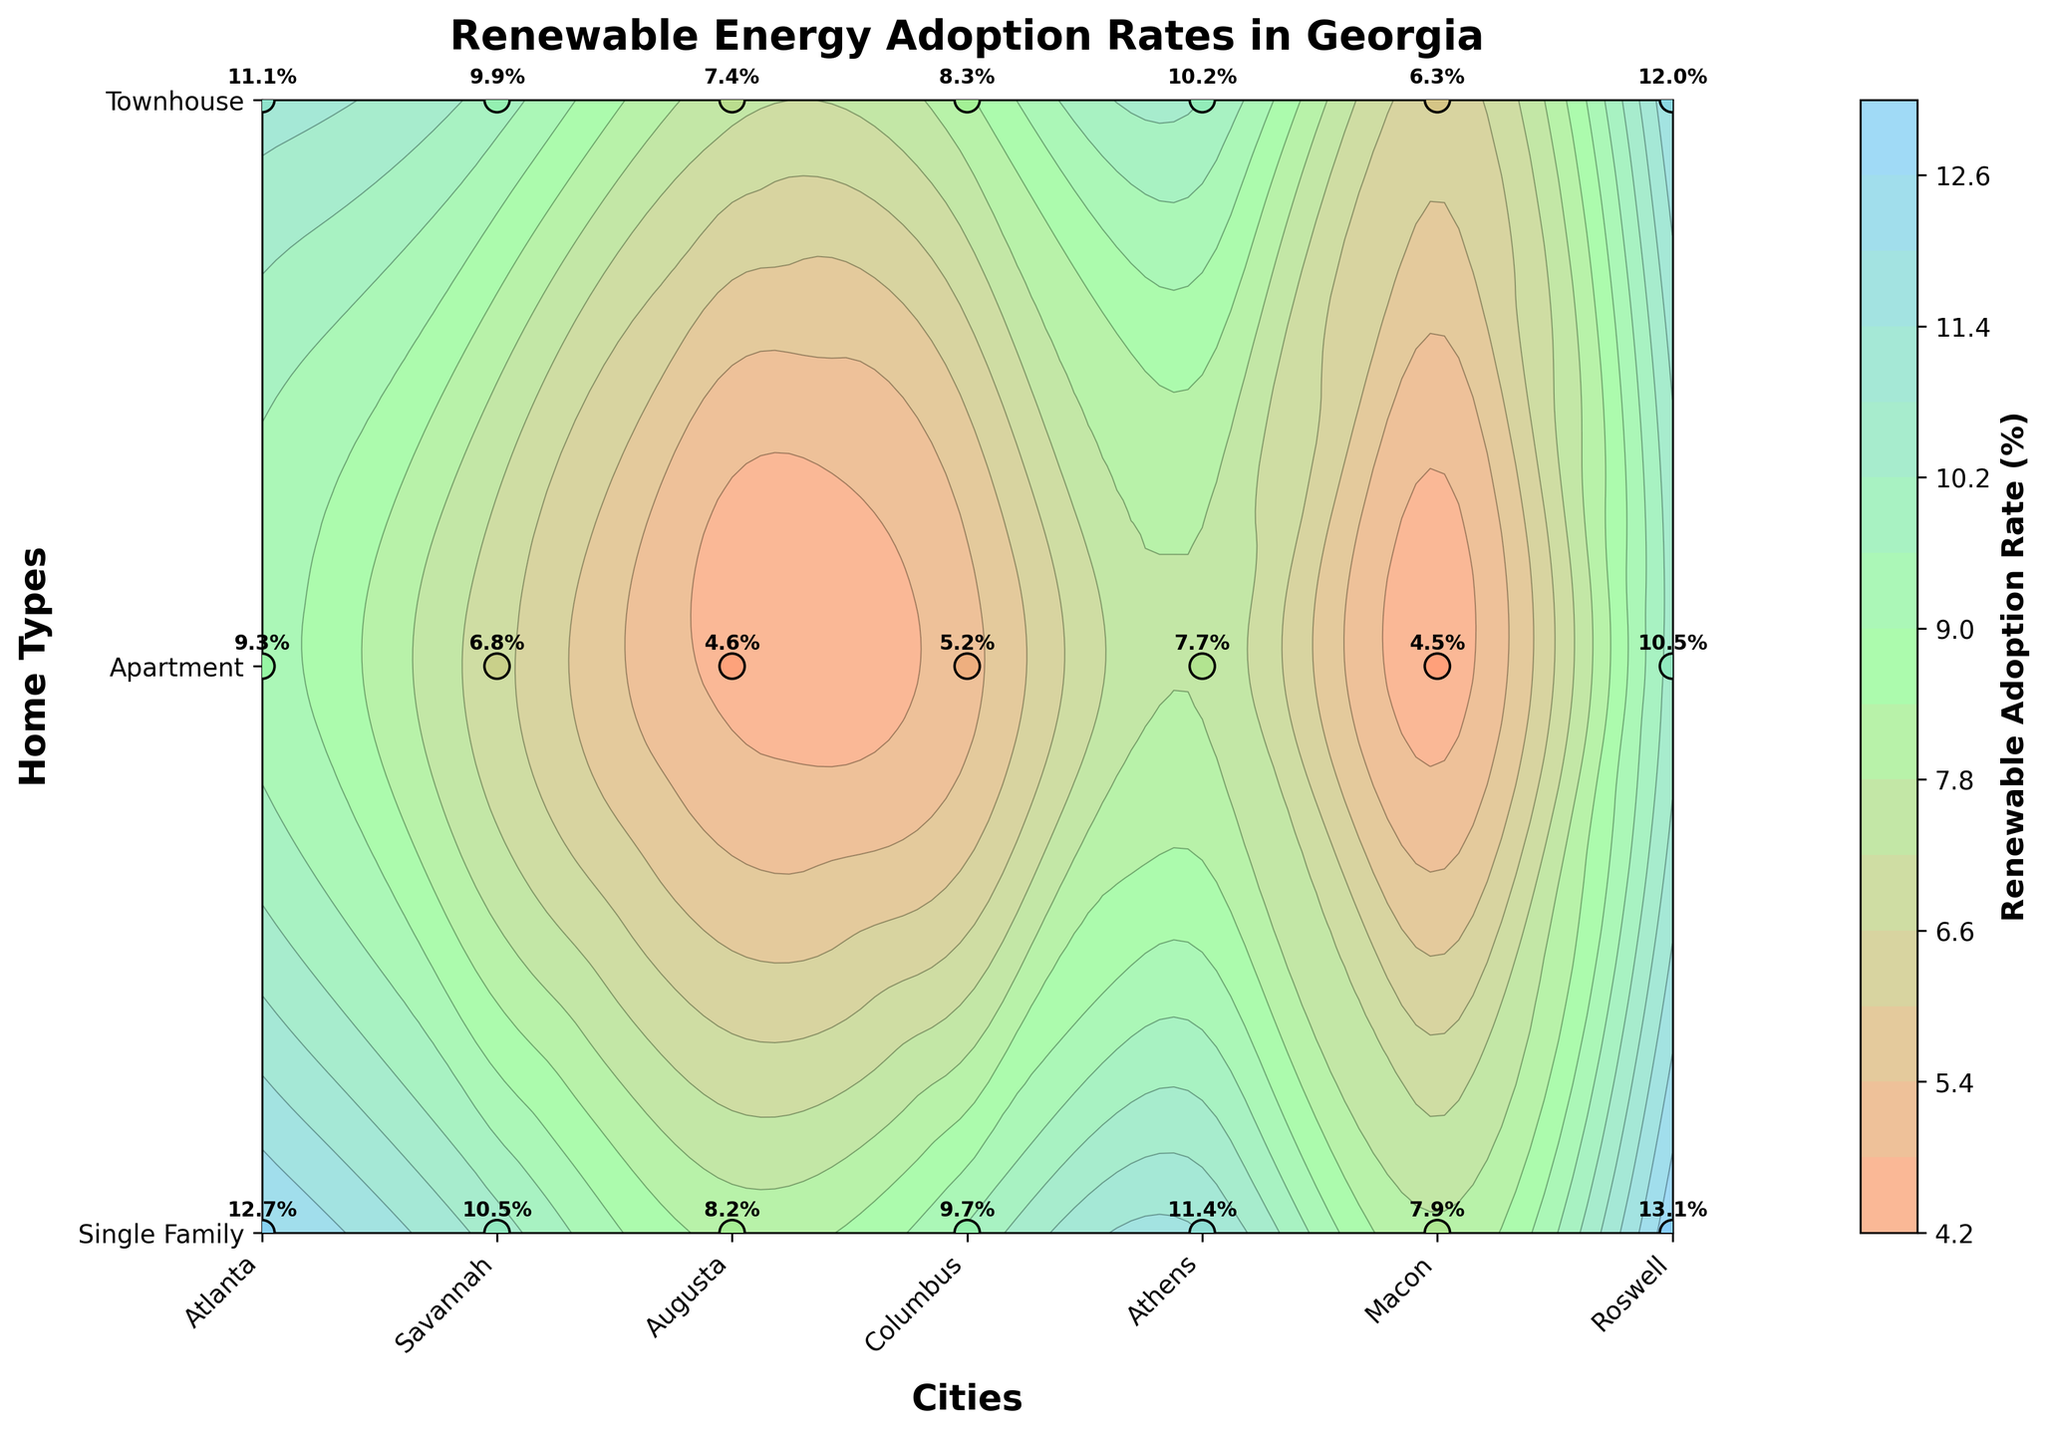What is the title of the plot? The title of the plot is displayed at the top center and usually provides a general idea about the plot's subject.
Answer: Renewable Energy Adoption Rates in Georgia Which city has the highest renewable adoption rate for single-family homes? Locate the single-family home type on the vertical axis and find the highest contour or label point across the horizontal axis representing different cities.
Answer: Roswell How many contour levels are present in the plot? Count the distinct color regions or refer to the contour level description in the legend or color bar.
Answer: 15 What is the renewable adoption rate for townhouses in Augusta? Locate Augusta on the horizontal axis and townhouses on the vertical axis, then find the corresponding label or contour value.
Answer: 7.4% Which city has the lowest renewable adoption rate for apartments? Compare the labeled rates for apartments across all cities displayed on the horizontal axis relative to apartments on the vertical axis.
Answer: Macon Which home type has the highest variation in renewable adoption rates across different cities? Observe the labels or colors across each horizontal strip representing a home type to determine which has the widest range or most significant color gradient.
Answer: Single Family What is the average renewable adoption rate for Atlanta across all home types? Add the adoption rates for all home types in Atlanta and divide by the number of home types. (12.7 + 9.3 + 11.1) / 3
Answer: 11.03% Compare the renewable adoption rate for townhouses in Columbus and Athens. Which is higher? Locate Columbus and Athens on the horizontal axis and find the values for townhouses on the vertical axis, then compare.
Answer: Athens (10.2% vs. 8.3%) What is the total renewable adoption rate for apartments in Savannah, Augusta, and Macon combined? Add the renewable adoption rates for apartments in these three cities (6.8 + 4.6 + 4.5).
Answer: 15.9% Are any cities showing a renewable adoption rate above 13%? If so, which ones and for which home types? Check the labels or contours for values above 13% and identify the corresponding cities and home types.
Answer: Only Roswell for Single Family (13.1%) 